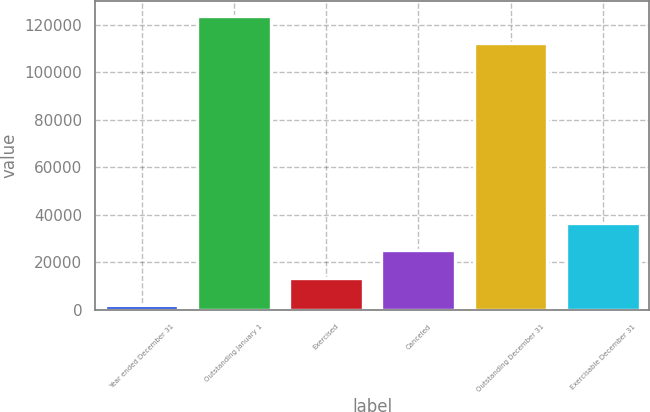Convert chart to OTSL. <chart><loc_0><loc_0><loc_500><loc_500><bar_chart><fcel>Year ended December 31<fcel>Outstanding January 1<fcel>Exercised<fcel>Canceled<fcel>Outstanding December 31<fcel>Exercisable December 31<nl><fcel>2004<fcel>123766<fcel>13585.8<fcel>25167.6<fcel>112184<fcel>36749.4<nl></chart> 